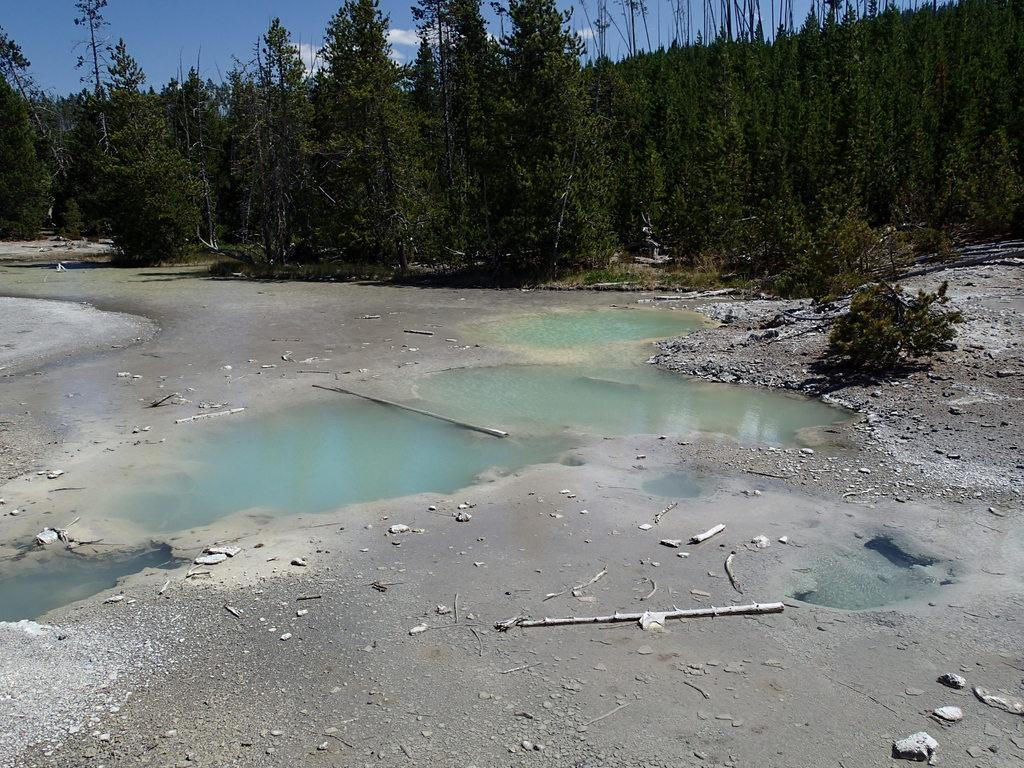What is the primary element visible in the image? There is water in the image. What types of vegetation can be seen in the image? There are plants and trees in the image. What can be seen in the background of the image? The sky is visible in the background of the image. What type of flesh can be seen hanging from the trees in the image? There is no flesh present in the image; it features water, plants, trees, and the sky. 